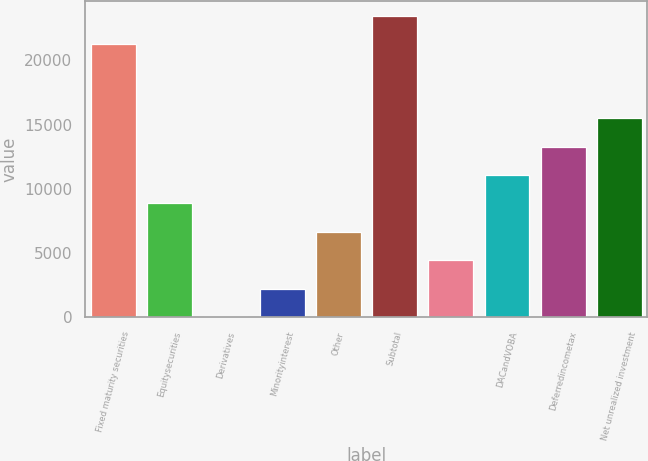<chart> <loc_0><loc_0><loc_500><loc_500><bar_chart><fcel>Fixed maturity securities<fcel>Equitysecurities<fcel>Derivatives<fcel>Minorityinterest<fcel>Other<fcel>Subtotal<fcel>Unnamed: 6<fcel>DACandVOBA<fcel>Deferredincometax<fcel>Net unrealized investment<nl><fcel>21246<fcel>8856.8<fcel>2<fcel>2215.7<fcel>6643.1<fcel>23459.7<fcel>4429.4<fcel>11070.5<fcel>13284.2<fcel>15497.9<nl></chart> 